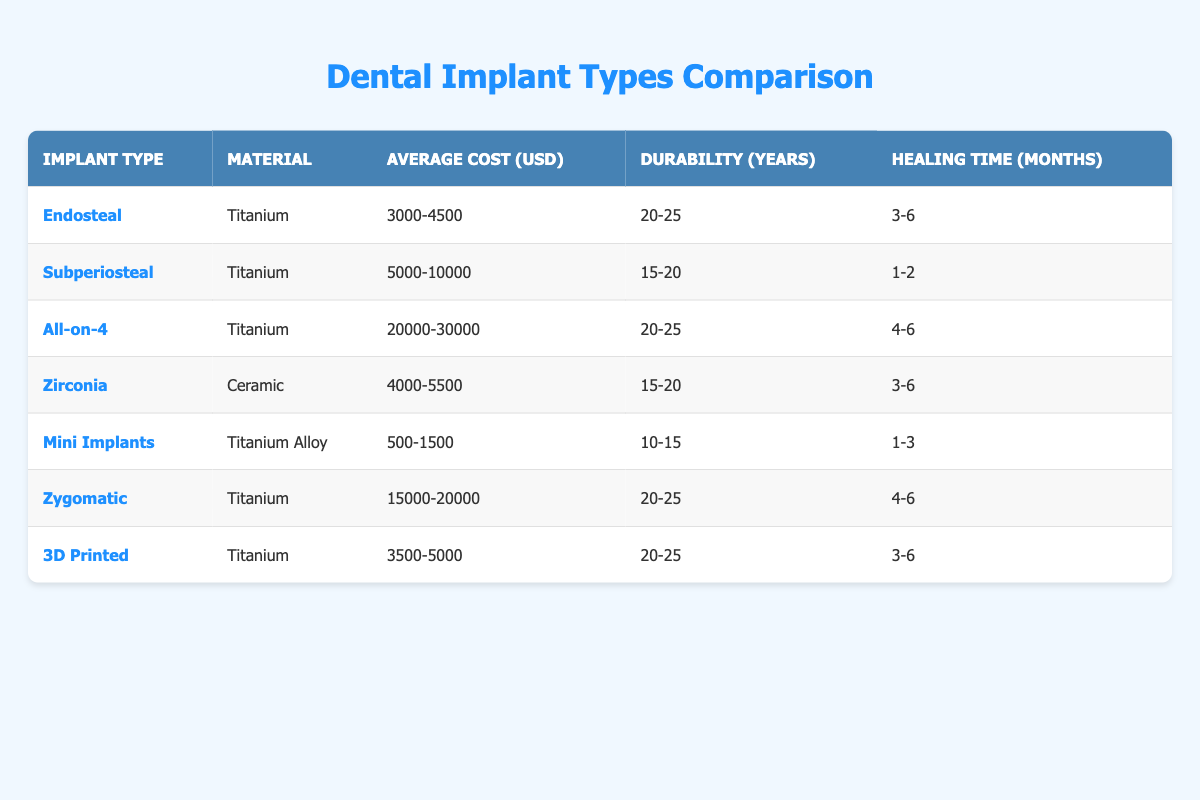What is the average cost range for Endosteal implants? The table indicates that the average cost for Endosteal implants is between 3000 to 4500 USD. This is a direct retrieval from the "Average Cost (USD)" column for the "Endosteal" row.
Answer: 3000-4500 USD Which implant type has the highest average cost? By comparing the average costs in the table, All-on-4 implants have the highest cost range of 20000 to 30000 USD. This is determined by scanning the "Average Cost (USD)" column for the highest figure.
Answer: All-on-4 Is the healing time for Zygomatic implants less than 4 months? The table shows that Zygomatic implants have a healing time of 4 to 6 months, which is not less than 4 months. Thus, the answer is based on directly checking the "Healing Time (Months)" column for the Zygomatic row.
Answer: No What is the average healing time for Mini Implants and Subperiosteal implants? From the table, Mini Implants have a healing time of 1 to 3 months, and Subperiosteal implants have a healing time of 1 to 2 months. The average can be calculated by summing the midpoints: (2 + 1.5)/2 = 1.75 months. This means checking each healing time range and averaging.
Answer: 1.75 months How many implant types have a durability of 20 years or more? The table lists the durability for each implant type. By counting the rows where the "Durability (Years)" falls in the range of 20 to 25, we see that Endosteal, All-on-4, Zygomatic, and 3D Printed implants fit this criterion. This requires evaluating the "Durability" column for qualifying entries.
Answer: 4 types What is the material used for the Mini Implants? The row for Mini Implants in the table specifies that the material used is Titanium Alloy. This is retrieved simply by looking at the "Material" column corresponding to Mini Implants.
Answer: Titanium Alloy Are Zirconia implants generally more durable than Mini Implants? The table shows that Zirconia implants have a durability range of 15 to 20 years while Mini Implants are in the range of 10 to 15 years. This indicates that Zirconia implants are indeed more durable, which is found by comparing the "Durability (Years)" columns for each type.
Answer: Yes Which implant type takes the least amount of healing time? By examining the "Healing Time (Months)" column, Mini Implants take 1 to 3 months, which is the shortest range compared to all other types listed. This involves checking the healing times across all implants.
Answer: Mini Implants 